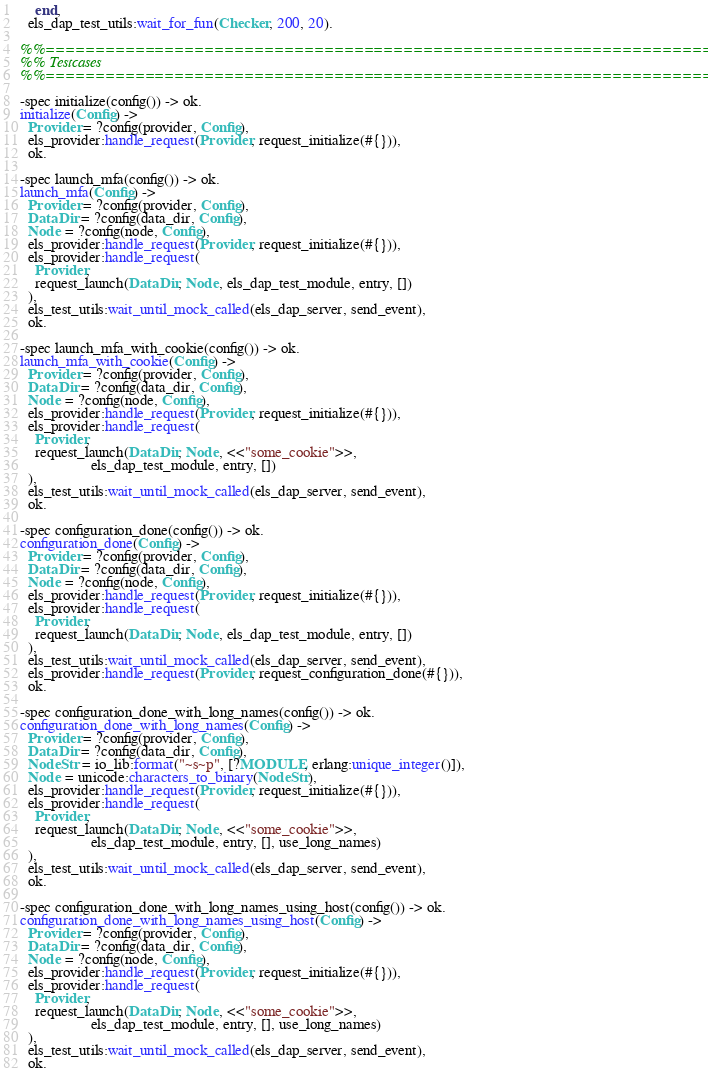<code> <loc_0><loc_0><loc_500><loc_500><_Erlang_>    end,
  els_dap_test_utils:wait_for_fun(Checker, 200, 20).

%%==============================================================================
%% Testcases
%%==============================================================================

-spec initialize(config()) -> ok.
initialize(Config) ->
  Provider = ?config(provider, Config),
  els_provider:handle_request(Provider, request_initialize(#{})),
  ok.

-spec launch_mfa(config()) -> ok.
launch_mfa(Config) ->
  Provider = ?config(provider, Config),
  DataDir = ?config(data_dir, Config),
  Node = ?config(node, Config),
  els_provider:handle_request(Provider, request_initialize(#{})),
  els_provider:handle_request(
    Provider,
    request_launch(DataDir, Node, els_dap_test_module, entry, [])
  ),
  els_test_utils:wait_until_mock_called(els_dap_server, send_event),
  ok.

-spec launch_mfa_with_cookie(config()) -> ok.
launch_mfa_with_cookie(Config) ->
  Provider = ?config(provider, Config),
  DataDir = ?config(data_dir, Config),
  Node = ?config(node, Config),
  els_provider:handle_request(Provider, request_initialize(#{})),
  els_provider:handle_request(
    Provider,
    request_launch(DataDir, Node, <<"some_cookie">>,
                   els_dap_test_module, entry, [])
  ),
  els_test_utils:wait_until_mock_called(els_dap_server, send_event),
  ok.

-spec configuration_done(config()) -> ok.
configuration_done(Config) ->
  Provider = ?config(provider, Config),
  DataDir = ?config(data_dir, Config),
  Node = ?config(node, Config),
  els_provider:handle_request(Provider, request_initialize(#{})),
  els_provider:handle_request(
    Provider,
    request_launch(DataDir, Node, els_dap_test_module, entry, [])
  ),
  els_test_utils:wait_until_mock_called(els_dap_server, send_event),
  els_provider:handle_request(Provider, request_configuration_done(#{})),
  ok.

-spec configuration_done_with_long_names(config()) -> ok.
configuration_done_with_long_names(Config) ->
  Provider = ?config(provider, Config),
  DataDir = ?config(data_dir, Config),
  NodeStr = io_lib:format("~s~p", [?MODULE, erlang:unique_integer()]),
  Node = unicode:characters_to_binary(NodeStr),
  els_provider:handle_request(Provider, request_initialize(#{})),
  els_provider:handle_request(
    Provider,
    request_launch(DataDir, Node, <<"some_cookie">>,
                   els_dap_test_module, entry, [], use_long_names)
  ),
  els_test_utils:wait_until_mock_called(els_dap_server, send_event),
  ok.

-spec configuration_done_with_long_names_using_host(config()) -> ok.
configuration_done_with_long_names_using_host(Config) ->
  Provider = ?config(provider, Config),
  DataDir = ?config(data_dir, Config),
  Node = ?config(node, Config),
  els_provider:handle_request(Provider, request_initialize(#{})),
  els_provider:handle_request(
    Provider,
    request_launch(DataDir, Node, <<"some_cookie">>,
                   els_dap_test_module, entry, [], use_long_names)
  ),
  els_test_utils:wait_until_mock_called(els_dap_server, send_event),
  ok.
</code> 